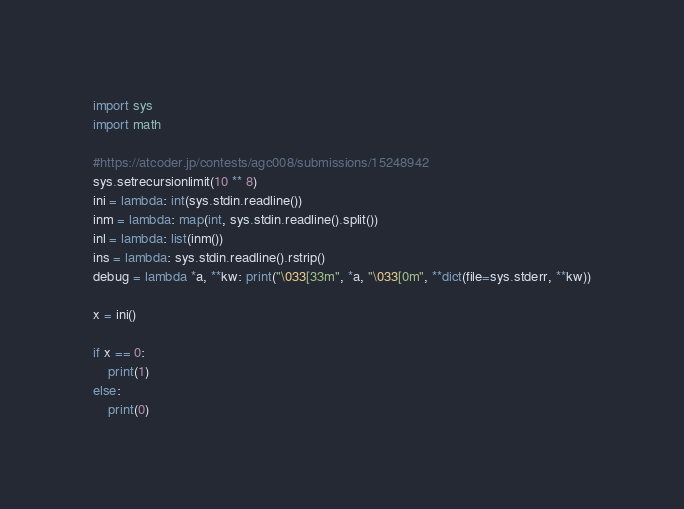Convert code to text. <code><loc_0><loc_0><loc_500><loc_500><_Python_>import sys
import math

#https://atcoder.jp/contests/agc008/submissions/15248942
sys.setrecursionlimit(10 ** 8)
ini = lambda: int(sys.stdin.readline())
inm = lambda: map(int, sys.stdin.readline().split())
inl = lambda: list(inm())
ins = lambda: sys.stdin.readline().rstrip()
debug = lambda *a, **kw: print("\033[33m", *a, "\033[0m", **dict(file=sys.stderr, **kw))

x = ini()

if x == 0:
    print(1)
else:
    print(0)</code> 